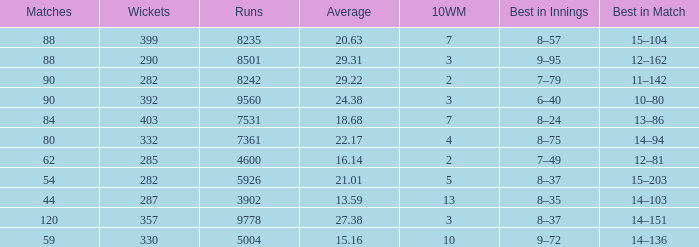What is the total number of wickets that have runs under 4600 and matches under 44? None. 